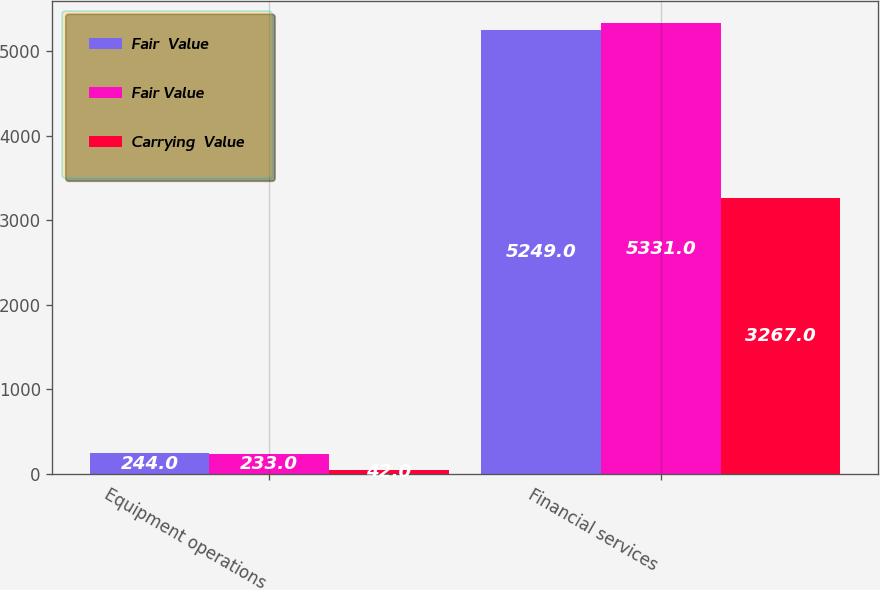Convert chart to OTSL. <chart><loc_0><loc_0><loc_500><loc_500><stacked_bar_chart><ecel><fcel>Equipment operations<fcel>Financial services<nl><fcel>Fair  Value<fcel>244<fcel>5249<nl><fcel>Fair Value<fcel>233<fcel>5331<nl><fcel>Carrying  Value<fcel>42<fcel>3267<nl></chart> 